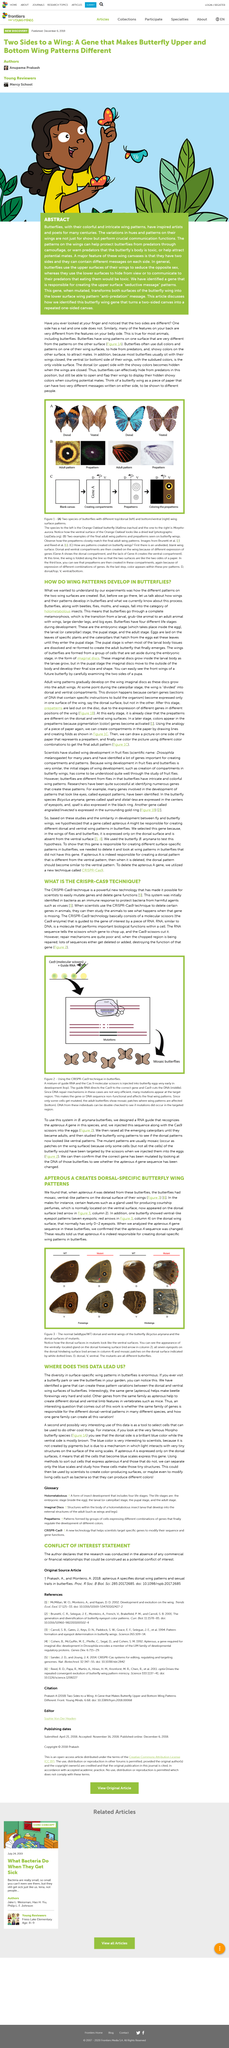Specify some key components in this picture. RNA is a molecule that performs vital biological functions within a cell. There was a difference observed between the males and females in terms of the location of the gland responsible for producing courtship perfumes, with this structure appearing on the dorsal surface in males and the normal ventral surface in females. The question of whether apterous A is responsible for creating dorsal-specific wing patterns in butterflies has been answered: Yes, apterous A is indeed responsible for creating these patterns. When the letter "A" was removed from the term "apterous A," the butterflies displayed irregular, patterned markings on the upper surface of their wings. RNA is a molecule that plays crucial roles in the biological processes within a cell. 